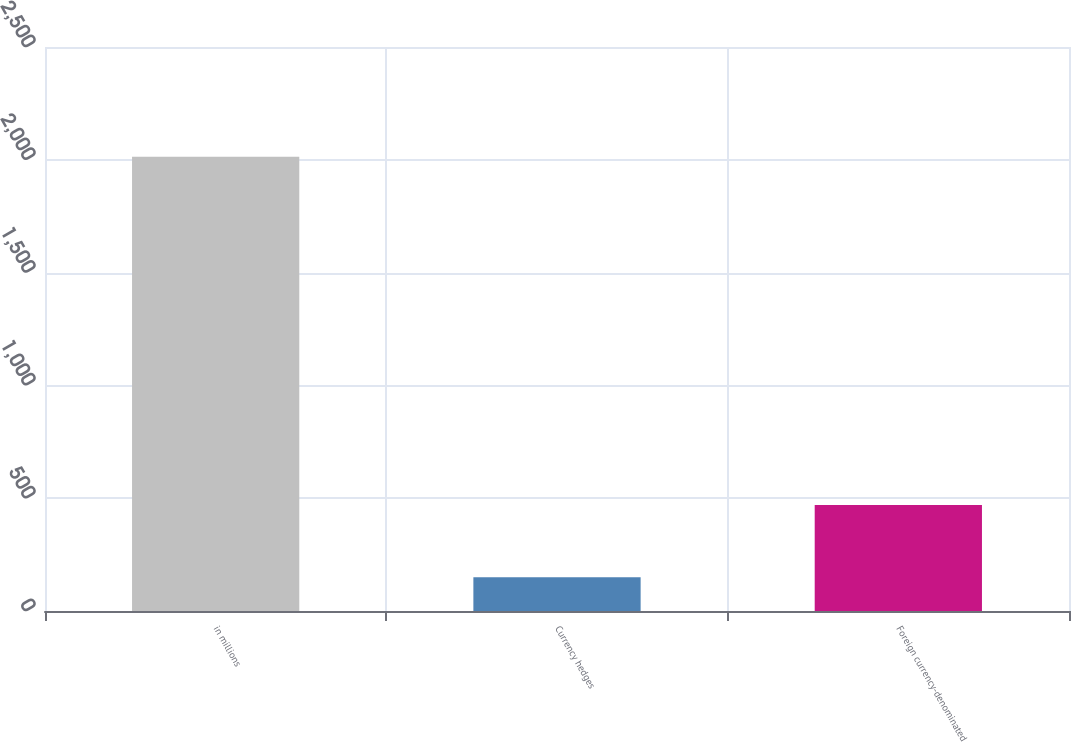Convert chart. <chart><loc_0><loc_0><loc_500><loc_500><bar_chart><fcel>in millions<fcel>Currency hedges<fcel>Foreign currency-denominated<nl><fcel>2013<fcel>150<fcel>470<nl></chart> 